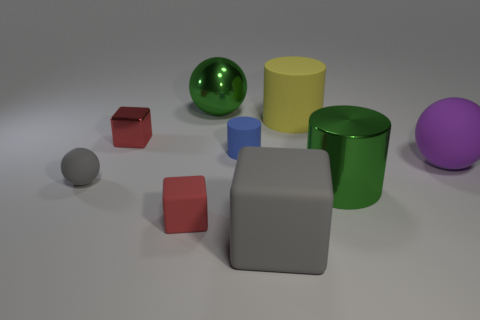What is the material of the thing that is the same color as the large cube?
Provide a short and direct response. Rubber. Are there any small rubber blocks that have the same color as the metal cube?
Offer a terse response. Yes. Is the metal ball the same color as the metallic cylinder?
Make the answer very short. Yes. There is a gray ball that is behind the big green metal cylinder; what is its size?
Offer a terse response. Small. Does the blue object have the same material as the green sphere?
Provide a succinct answer. No. The other gray thing that is the same material as the tiny gray thing is what shape?
Make the answer very short. Cube. Is there any other thing that has the same color as the tiny rubber cylinder?
Keep it short and to the point. No. The ball that is to the right of the big metallic sphere is what color?
Your response must be concise. Purple. Is the color of the shiny object that is behind the yellow cylinder the same as the big block?
Make the answer very short. No. There is a blue thing that is the same shape as the large yellow object; what is it made of?
Offer a terse response. Rubber. 